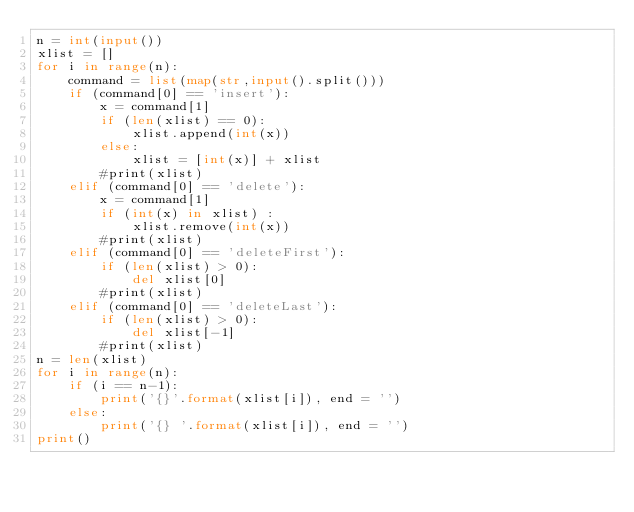<code> <loc_0><loc_0><loc_500><loc_500><_Python_>n = int(input())
xlist = []
for i in range(n):
    command = list(map(str,input().split()))
    if (command[0] == 'insert'):
        x = command[1]
        if (len(xlist) == 0):
            xlist.append(int(x))
        else:
            xlist = [int(x)] + xlist
        #print(xlist)
    elif (command[0] == 'delete'):
        x = command[1]
        if (int(x) in xlist) :
            xlist.remove(int(x))
        #print(xlist)
    elif (command[0] == 'deleteFirst'):
        if (len(xlist) > 0):
            del xlist[0]
        #print(xlist)
    elif (command[0] == 'deleteLast'):
        if (len(xlist) > 0):
            del xlist[-1]
        #print(xlist)
n = len(xlist)
for i in range(n):
    if (i == n-1):
        print('{}'.format(xlist[i]), end = '')
    else:
        print('{} '.format(xlist[i]), end = '')
print()
</code> 